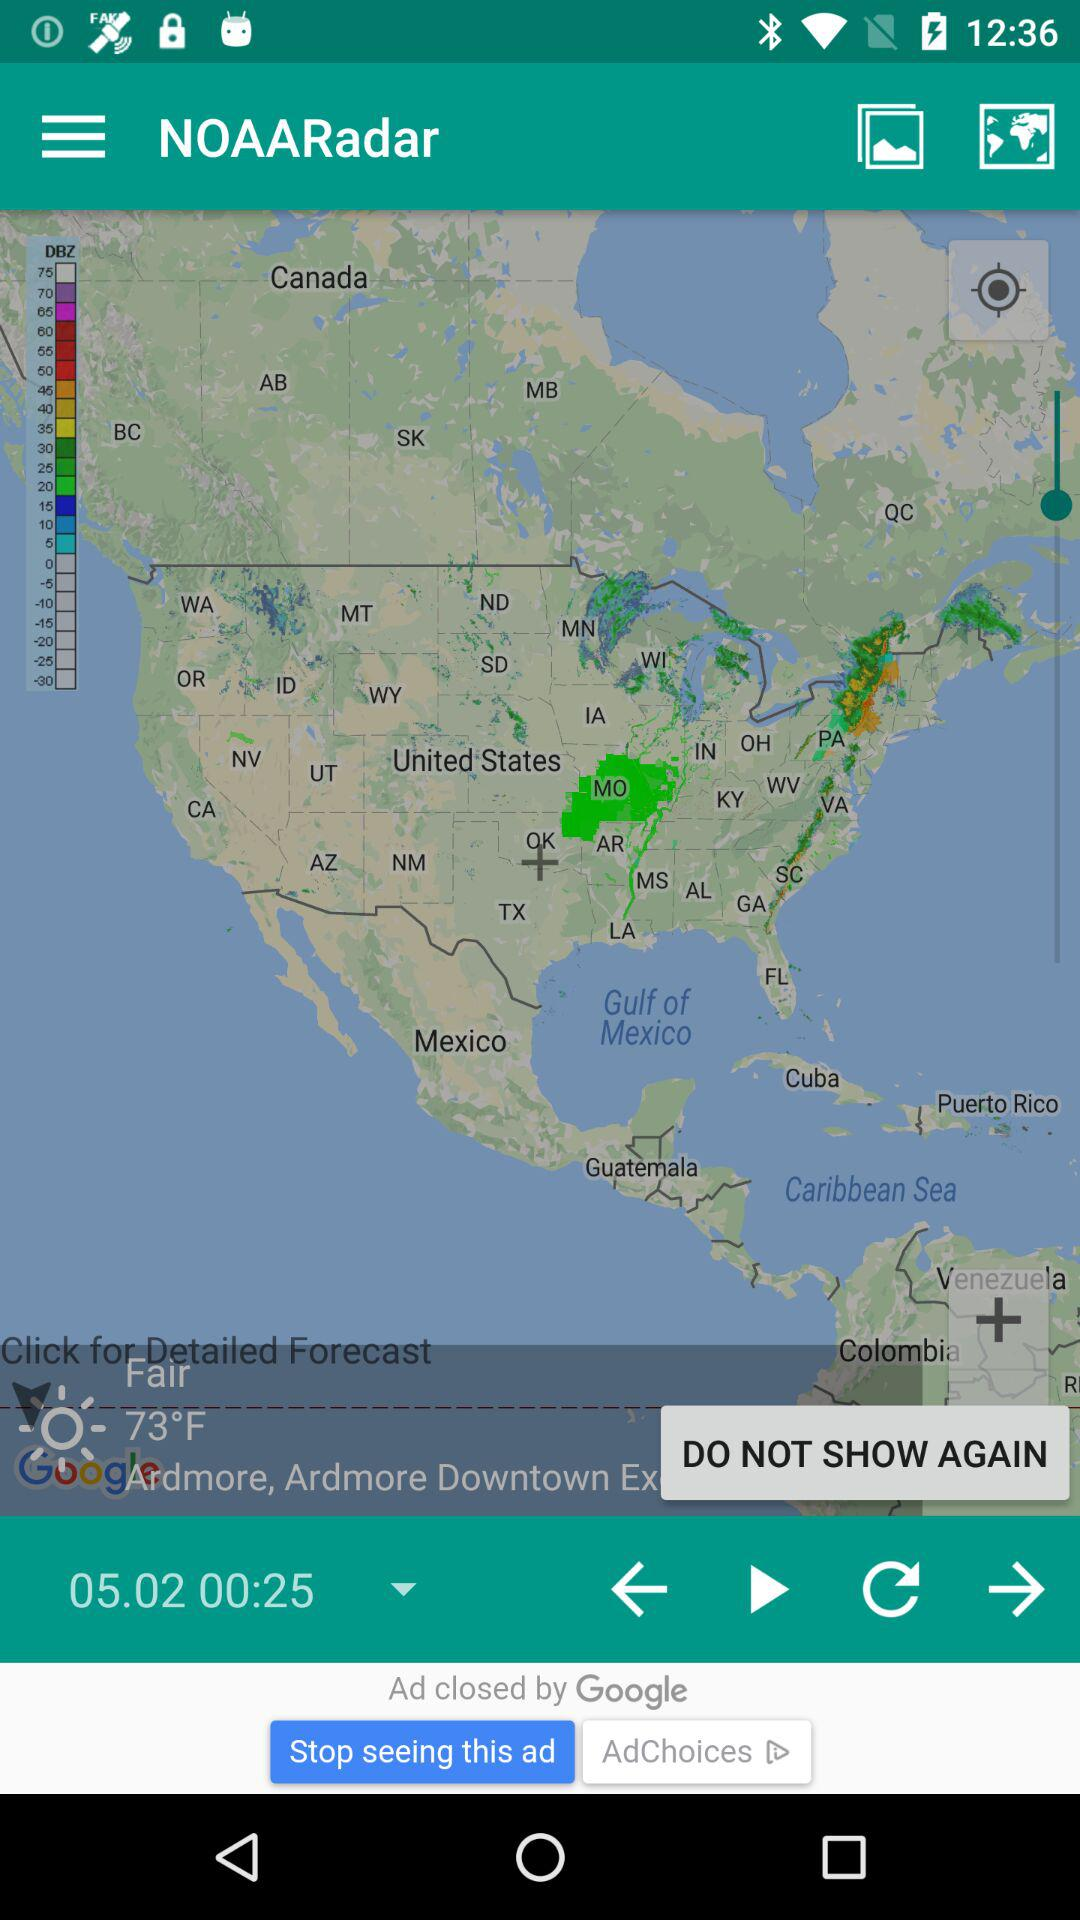What is the app name? The app name is "NOAARadar". 